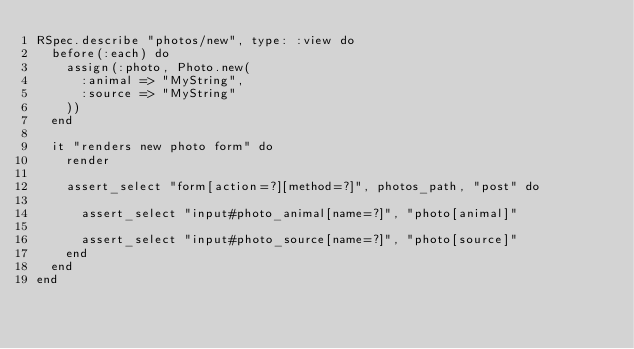Convert code to text. <code><loc_0><loc_0><loc_500><loc_500><_Ruby_>RSpec.describe "photos/new", type: :view do
  before(:each) do
    assign(:photo, Photo.new(
      :animal => "MyString",
      :source => "MyString"
    ))
  end

  it "renders new photo form" do
    render

    assert_select "form[action=?][method=?]", photos_path, "post" do

      assert_select "input#photo_animal[name=?]", "photo[animal]"

      assert_select "input#photo_source[name=?]", "photo[source]"
    end
  end
end
</code> 